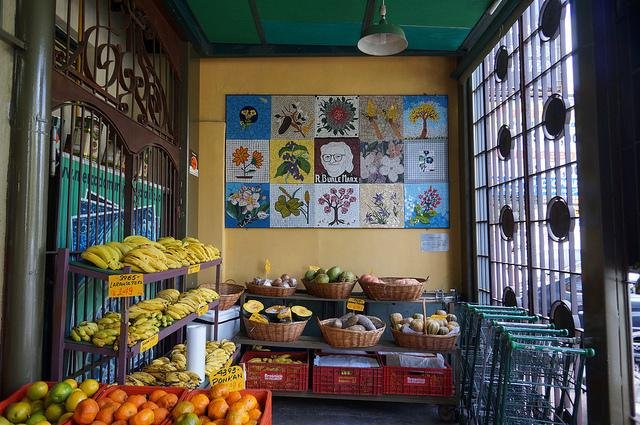Why are the fruits in the basket? selling 